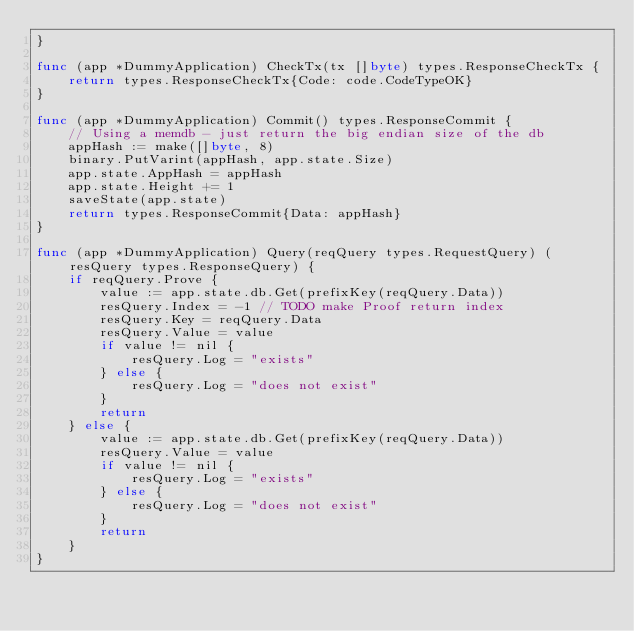<code> <loc_0><loc_0><loc_500><loc_500><_Go_>}

func (app *DummyApplication) CheckTx(tx []byte) types.ResponseCheckTx {
	return types.ResponseCheckTx{Code: code.CodeTypeOK}
}

func (app *DummyApplication) Commit() types.ResponseCommit {
	// Using a memdb - just return the big endian size of the db
	appHash := make([]byte, 8)
	binary.PutVarint(appHash, app.state.Size)
	app.state.AppHash = appHash
	app.state.Height += 1
	saveState(app.state)
	return types.ResponseCommit{Data: appHash}
}

func (app *DummyApplication) Query(reqQuery types.RequestQuery) (resQuery types.ResponseQuery) {
	if reqQuery.Prove {
		value := app.state.db.Get(prefixKey(reqQuery.Data))
		resQuery.Index = -1 // TODO make Proof return index
		resQuery.Key = reqQuery.Data
		resQuery.Value = value
		if value != nil {
			resQuery.Log = "exists"
		} else {
			resQuery.Log = "does not exist"
		}
		return
	} else {
		value := app.state.db.Get(prefixKey(reqQuery.Data))
		resQuery.Value = value
		if value != nil {
			resQuery.Log = "exists"
		} else {
			resQuery.Log = "does not exist"
		}
		return
	}
}
</code> 